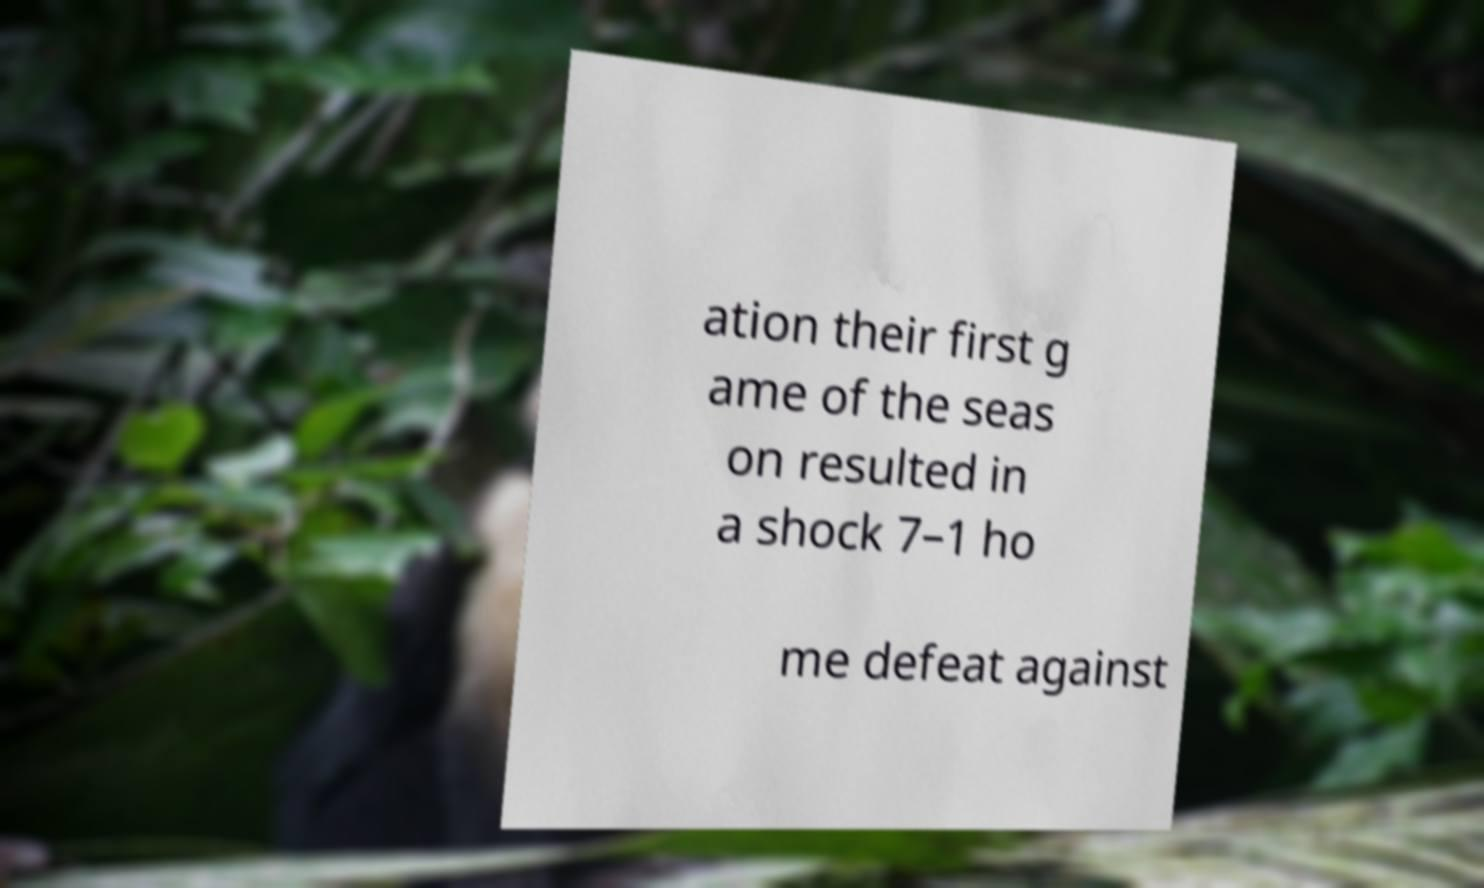Please read and relay the text visible in this image. What does it say? ation their first g ame of the seas on resulted in a shock 7–1 ho me defeat against 